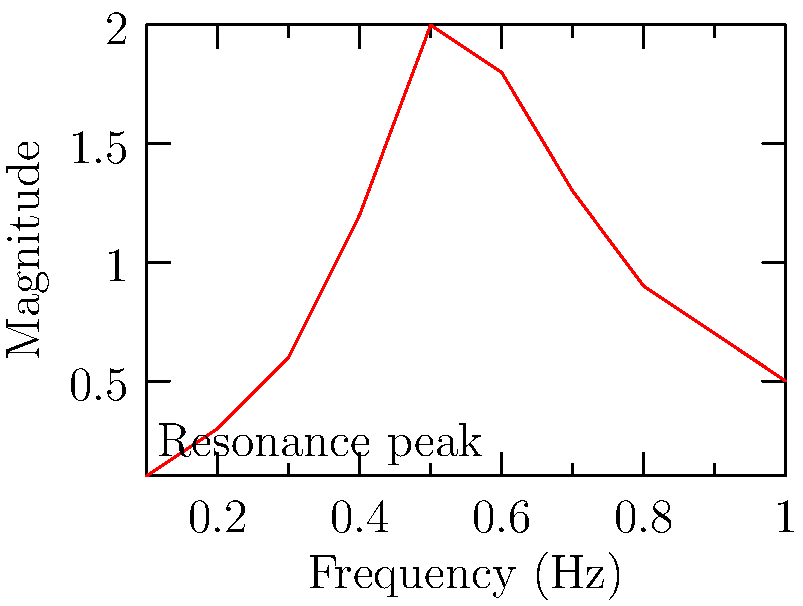Given the magnitude response of an RLC circuit shown in the graph, write an R function to estimate the resonant frequency and quality factor (Q) of the circuit. The function should take the frequency and magnitude data as inputs and return a list containing the estimated resonant frequency and Q factor. To solve this problem, we need to follow these steps:

1. Identify the resonant frequency:
   The resonant frequency ($f_r$) is where the magnitude response peaks. From the graph, it appears to be around 0.5 Hz.

2. Estimate the quality factor (Q):
   Q can be estimated using the formula: $Q = \frac{f_r}{\Delta f}$
   where $\Delta f$ is the bandwidth at 70.7% of the peak magnitude (also known as the -3dB points).

3. Write an R function to automate this process:

```r
estimate_rlc_params <- function(freq, mag) {
  # Find the resonant frequency
  fr_index <- which.max(mag)
  fr <- freq[fr_index]
  
  # Find the peak magnitude
  peak_mag <- max(mag)
  
  # Find the -3dB points
  threshold <- peak_mag / sqrt(2)
  lower_index <- max(which(mag[1:fr_index] <= threshold))
  upper_index <- fr_index - 1 + min(which(mag[fr_index:length(mag)] <= threshold))
  
  # Calculate bandwidth
  bandwidth <- freq[upper_index] - freq[lower_index]
  
  # Calculate Q factor
  Q <- fr / bandwidth
  
  # Return results
  return(list(resonant_frequency = fr, Q_factor = Q))
}
```

4. The function can be used as follows:

```r
f <- c(0.1, 0.2, 0.3, 0.4, 0.5, 0.6, 0.7, 0.8, 0.9, 1.0)
mag <- c(0.1, 0.3, 0.6, 1.2, 2.0, 1.8, 1.3, 0.9, 0.7, 0.5)
result <- estimate_rlc_params(f, mag)
print(result)
```

This function estimates the resonant frequency by finding the frequency at which the magnitude is maximum. It then calculates the Q factor using the -3dB bandwidth method.
Answer: estimate_rlc_params <- function(freq, mag) {
  fr_index <- which.max(mag)
  fr <- freq[fr_index]
  peak_mag <- max(mag)
  threshold <- peak_mag / sqrt(2)
  lower_index <- max(which(mag[1:fr_index] <= threshold))
  upper_index <- fr_index - 1 + min(which(mag[fr_index:length(mag)] <= threshold))
  bandwidth <- freq[upper_index] - freq[lower_index]
  Q <- fr / bandwidth
  return(list(resonant_frequency = fr, Q_factor = Q))
} 